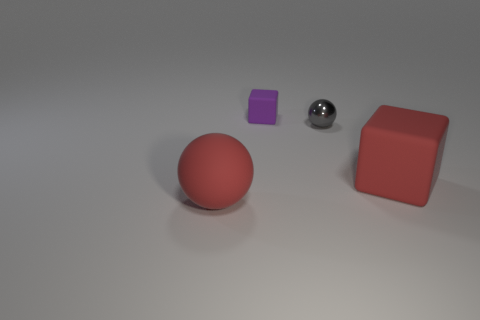What number of tiny gray shiny objects are left of the large red rubber thing to the right of the ball right of the small rubber thing? 1 